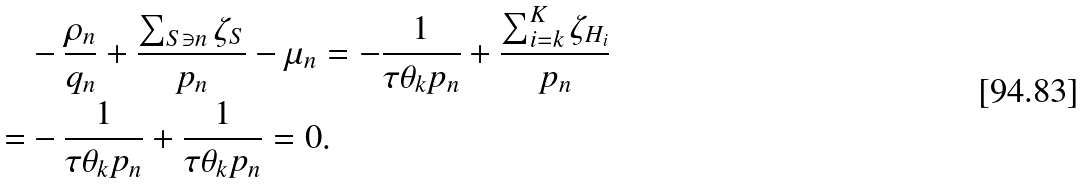Convert formula to latex. <formula><loc_0><loc_0><loc_500><loc_500>& - \frac { \rho _ { n } } { q _ { n } } + \frac { \sum _ { S \ni n } \zeta _ { S } } { p _ { n } } - \mu _ { n } = - \frac { 1 } { \tau \theta _ { k } p _ { n } } + \frac { \sum _ { i = k } ^ { K } \zeta _ { H _ { i } } } { p _ { n } } \\ = & - \frac { 1 } { \tau \theta _ { k } p _ { n } } + \frac { 1 } { \tau \theta _ { k } p _ { n } } = 0 .</formula> 